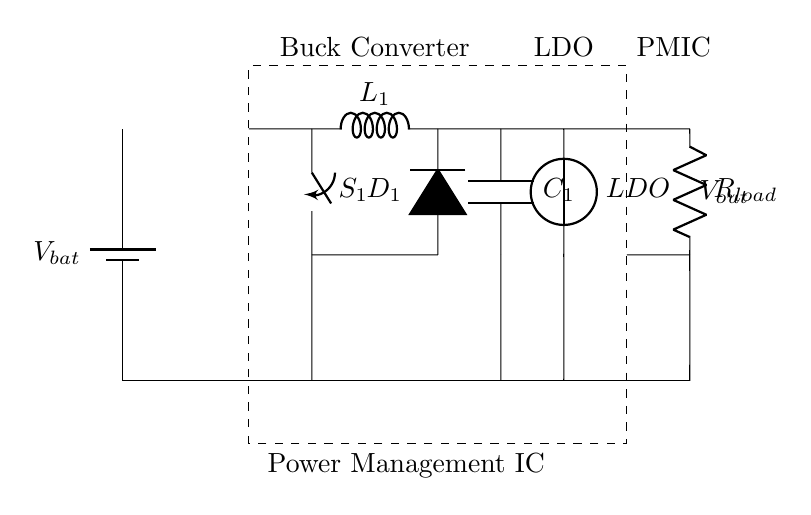What is the main function of the PMIC? The PMIC stands for Power Management Integrated Circuit, and its main function is to manage power distribution and efficiency in mobile devices. It optimizes battery usage by regulating voltage and current for various components.
Answer: Power management What type of converter is used in this circuit? The circuit includes a buck converter, which steps down the voltage from the battery to a lower voltage suitable for the load. The buck converter is indicated by the label and components that enforce voltage reduction.
Answer: Buck converter How many capacitors are present in the circuit? The circuit contains one capacitor, labeled C1, which is responsible for filtering and stabilizing the output voltage. The presence of only one capacitor is directly observable in the diagram.
Answer: One What is the role of the switch S1? The switch S1 controls the flow of current in the buck converter circuit, allowing it to be turned on or off as needed. It directly affects the operation of the inductor and the overall power efficiency when managing load demands.
Answer: Current control What is the voltage source used in the LDO section? The LDO section utilizes an European voltage source, which provides a stable and regulated output voltage to further supply the load. It ensures voltage stability despite variations in input conditions.
Answer: LDO What component is used to convert AC to DC? While the circuit does not explicitly show an AC-DC converter, it primarily relies on the PMIC and associated components to regulate the power supply for the smartphone. The circuit does not require a discrete AC-DC converter element since it assumes a direct DC input from the battery.
Answer: Not applicable How does the PMIC improve battery efficiency? The PMIC improves battery efficiency by utilizing both buck converter and LDO technologies to regulate power delivery based on demand, reducing unnecessary energy loss and optimizing performance throughout the device's operation. This functionality is integral for maintaining longer battery life in smartphones.
Answer: Efficiency optimization 